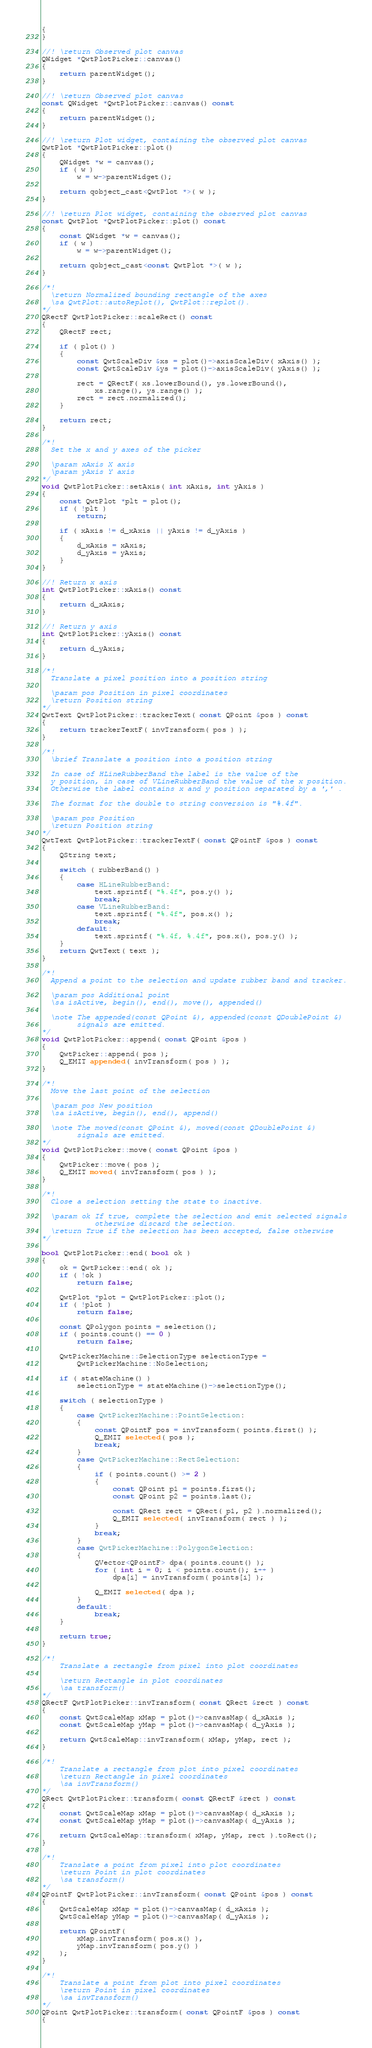Convert code to text. <code><loc_0><loc_0><loc_500><loc_500><_C++_>{
}

//! \return Observed plot canvas
QWidget *QwtPlotPicker::canvas()
{
    return parentWidget();
}

//! \return Observed plot canvas
const QWidget *QwtPlotPicker::canvas() const
{
    return parentWidget();
}

//! \return Plot widget, containing the observed plot canvas
QwtPlot *QwtPlotPicker::plot()
{
    QWidget *w = canvas();
    if ( w )
        w = w->parentWidget();

    return qobject_cast<QwtPlot *>( w );
}

//! \return Plot widget, containing the observed plot canvas
const QwtPlot *QwtPlotPicker::plot() const
{
    const QWidget *w = canvas();
    if ( w )
        w = w->parentWidget();

    return qobject_cast<const QwtPlot *>( w );
}

/*!
  \return Normalized bounding rectangle of the axes
  \sa QwtPlot::autoReplot(), QwtPlot::replot().
*/
QRectF QwtPlotPicker::scaleRect() const
{
    QRectF rect;

    if ( plot() )
    {
        const QwtScaleDiv &xs = plot()->axisScaleDiv( xAxis() );
        const QwtScaleDiv &ys = plot()->axisScaleDiv( yAxis() );

        rect = QRectF( xs.lowerBound(), ys.lowerBound(),
            xs.range(), ys.range() );
        rect = rect.normalized();
    }

    return rect;
}

/*!
  Set the x and y axes of the picker

  \param xAxis X axis
  \param yAxis Y axis
*/
void QwtPlotPicker::setAxis( int xAxis, int yAxis )
{
    const QwtPlot *plt = plot();
    if ( !plt )
        return;

    if ( xAxis != d_xAxis || yAxis != d_yAxis )
    {
        d_xAxis = xAxis;
        d_yAxis = yAxis;
    }
}

//! Return x axis
int QwtPlotPicker::xAxis() const
{
    return d_xAxis;
}

//! Return y axis
int QwtPlotPicker::yAxis() const
{
    return d_yAxis;
}

/*!
  Translate a pixel position into a position string

  \param pos Position in pixel coordinates
  \return Position string
*/
QwtText QwtPlotPicker::trackerText( const QPoint &pos ) const
{
    return trackerTextF( invTransform( pos ) );
}

/*!
  \brief Translate a position into a position string

  In case of HLineRubberBand the label is the value of the
  y position, in case of VLineRubberBand the value of the x position.
  Otherwise the label contains x and y position separated by a ',' .

  The format for the double to string conversion is "%.4f".

  \param pos Position
  \return Position string
*/
QwtText QwtPlotPicker::trackerTextF( const QPointF &pos ) const
{
    QString text;

    switch ( rubberBand() )
    {
        case HLineRubberBand:
            text.sprintf( "%.4f", pos.y() );
            break;
        case VLineRubberBand:
            text.sprintf( "%.4f", pos.x() );
            break;
        default:
            text.sprintf( "%.4f, %.4f", pos.x(), pos.y() );
    }
    return QwtText( text );
}

/*!
  Append a point to the selection and update rubber band and tracker.

  \param pos Additional point
  \sa isActive, begin(), end(), move(), appended()

  \note The appended(const QPoint &), appended(const QDoublePoint &)
        signals are emitted.
*/
void QwtPlotPicker::append( const QPoint &pos )
{
    QwtPicker::append( pos );
    Q_EMIT appended( invTransform( pos ) );
}

/*!
  Move the last point of the selection

  \param pos New position
  \sa isActive, begin(), end(), append()

  \note The moved(const QPoint &), moved(const QDoublePoint &)
        signals are emitted.
*/
void QwtPlotPicker::move( const QPoint &pos )
{
    QwtPicker::move( pos );
    Q_EMIT moved( invTransform( pos ) );
}

/*!
  Close a selection setting the state to inactive.

  \param ok If true, complete the selection and emit selected signals
            otherwise discard the selection.
  \return True if the selection has been accepted, false otherwise
*/

bool QwtPlotPicker::end( bool ok )
{
    ok = QwtPicker::end( ok );
    if ( !ok )
        return false;

    QwtPlot *plot = QwtPlotPicker::plot();
    if ( !plot )
        return false;

    const QPolygon points = selection();
    if ( points.count() == 0 )
        return false;

    QwtPickerMachine::SelectionType selectionType =
        QwtPickerMachine::NoSelection;

    if ( stateMachine() )
        selectionType = stateMachine()->selectionType();

    switch ( selectionType )
    {
        case QwtPickerMachine::PointSelection:
        {
            const QPointF pos = invTransform( points.first() );
            Q_EMIT selected( pos );
            break;
        }
        case QwtPickerMachine::RectSelection:
        {
            if ( points.count() >= 2 )
            {
                const QPoint p1 = points.first();
                const QPoint p2 = points.last();

                const QRect rect = QRect( p1, p2 ).normalized();
                Q_EMIT selected( invTransform( rect ) );
            }
            break;
        }
        case QwtPickerMachine::PolygonSelection:
        {
            QVector<QPointF> dpa( points.count() );
            for ( int i = 0; i < points.count(); i++ )
                dpa[i] = invTransform( points[i] );

            Q_EMIT selected( dpa );
        }
        default:
            break;
    }

    return true;
}

/*!
    Translate a rectangle from pixel into plot coordinates

    \return Rectangle in plot coordinates
    \sa transform()
*/
QRectF QwtPlotPicker::invTransform( const QRect &rect ) const
{
    const QwtScaleMap xMap = plot()->canvasMap( d_xAxis );
    const QwtScaleMap yMap = plot()->canvasMap( d_yAxis );

    return QwtScaleMap::invTransform( xMap, yMap, rect );
}

/*!
    Translate a rectangle from plot into pixel coordinates
    \return Rectangle in pixel coordinates
    \sa invTransform()
*/
QRect QwtPlotPicker::transform( const QRectF &rect ) const
{
    const QwtScaleMap xMap = plot()->canvasMap( d_xAxis );
    const QwtScaleMap yMap = plot()->canvasMap( d_yAxis );

    return QwtScaleMap::transform( xMap, yMap, rect ).toRect();
}

/*!
    Translate a point from pixel into plot coordinates
    \return Point in plot coordinates
    \sa transform()
*/
QPointF QwtPlotPicker::invTransform( const QPoint &pos ) const
{
    QwtScaleMap xMap = plot()->canvasMap( d_xAxis );
    QwtScaleMap yMap = plot()->canvasMap( d_yAxis );

    return QPointF(
        xMap.invTransform( pos.x() ),
        yMap.invTransform( pos.y() )
    );
}

/*!
    Translate a point from plot into pixel coordinates
    \return Point in pixel coordinates
    \sa invTransform()
*/
QPoint QwtPlotPicker::transform( const QPointF &pos ) const
{</code> 